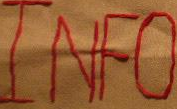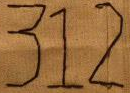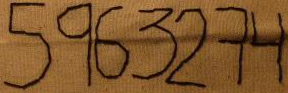What words can you see in these images in sequence, separated by a semicolon? INFO; 312; 5963274 